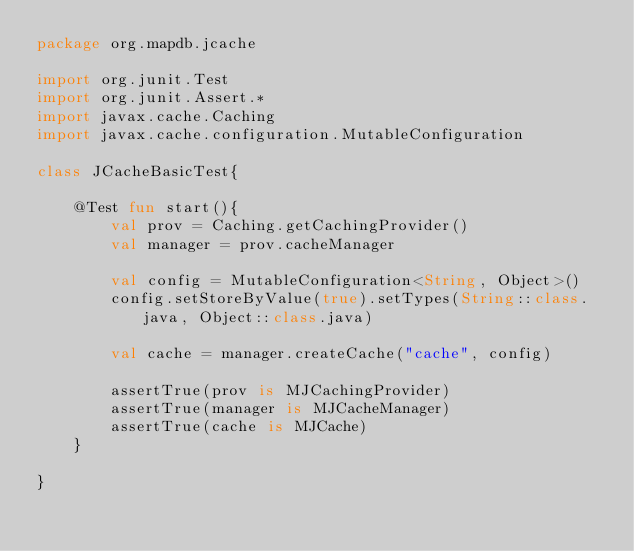Convert code to text. <code><loc_0><loc_0><loc_500><loc_500><_Kotlin_>package org.mapdb.jcache

import org.junit.Test
import org.junit.Assert.*
import javax.cache.Caching
import javax.cache.configuration.MutableConfiguration

class JCacheBasicTest{

    @Test fun start(){
        val prov = Caching.getCachingProvider()
        val manager = prov.cacheManager

        val config = MutableConfiguration<String, Object>()
        config.setStoreByValue(true).setTypes(String::class.java, Object::class.java)

        val cache = manager.createCache("cache", config)

        assertTrue(prov is MJCachingProvider)
        assertTrue(manager is MJCacheManager)
        assertTrue(cache is MJCache)
    }

}</code> 